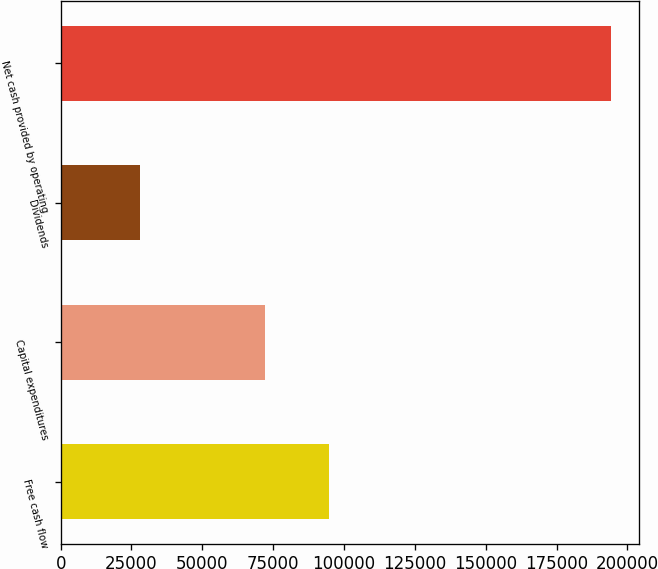Convert chart to OTSL. <chart><loc_0><loc_0><loc_500><loc_500><bar_chart><fcel>Free cash flow<fcel>Capital expenditures<fcel>Dividends<fcel>Net cash provided by operating<nl><fcel>94536<fcel>72008<fcel>27861<fcel>194405<nl></chart> 